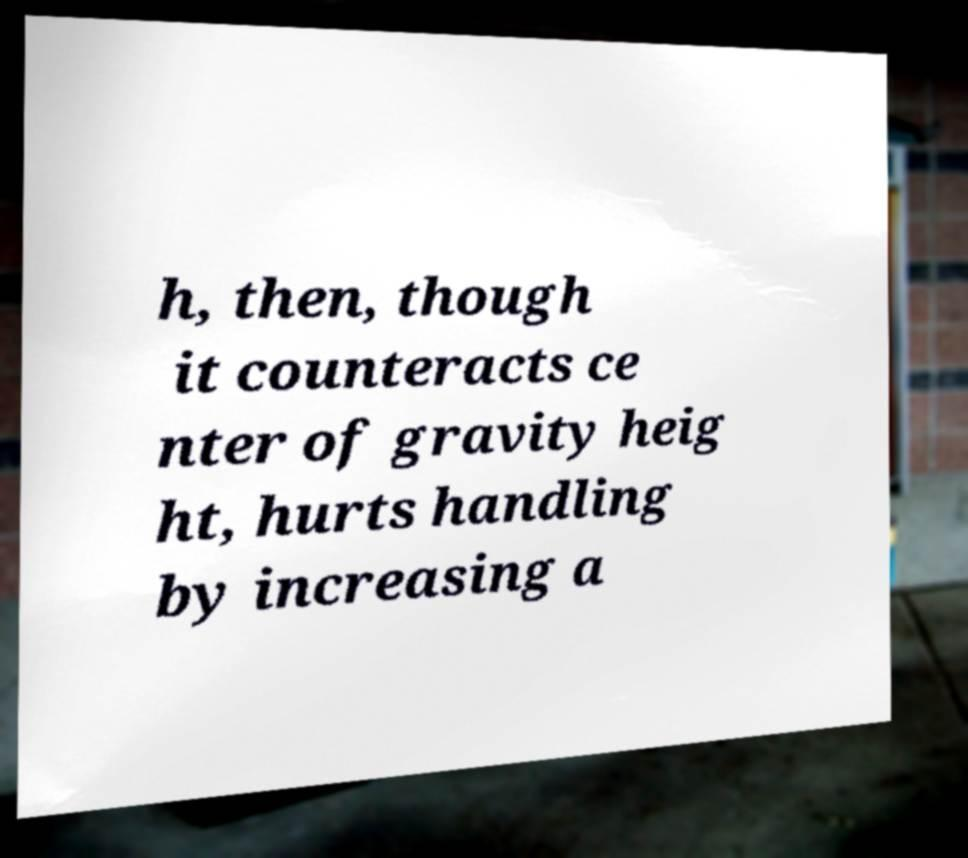For documentation purposes, I need the text within this image transcribed. Could you provide that? h, then, though it counteracts ce nter of gravity heig ht, hurts handling by increasing a 